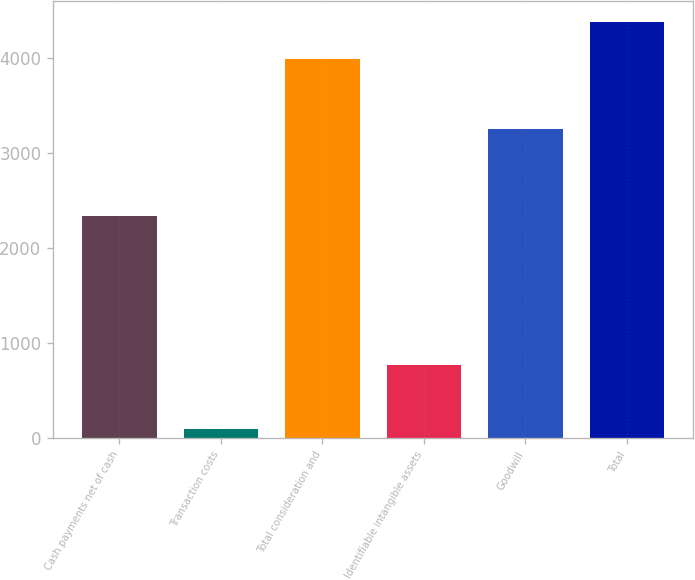<chart> <loc_0><loc_0><loc_500><loc_500><bar_chart><fcel>Cash payments net of cash<fcel>Transaction costs<fcel>Total consideration and<fcel>Identifiable intangible assets<fcel>Goodwill<fcel>Total<nl><fcel>2343<fcel>91<fcel>3998<fcel>770<fcel>3253<fcel>4388.7<nl></chart> 